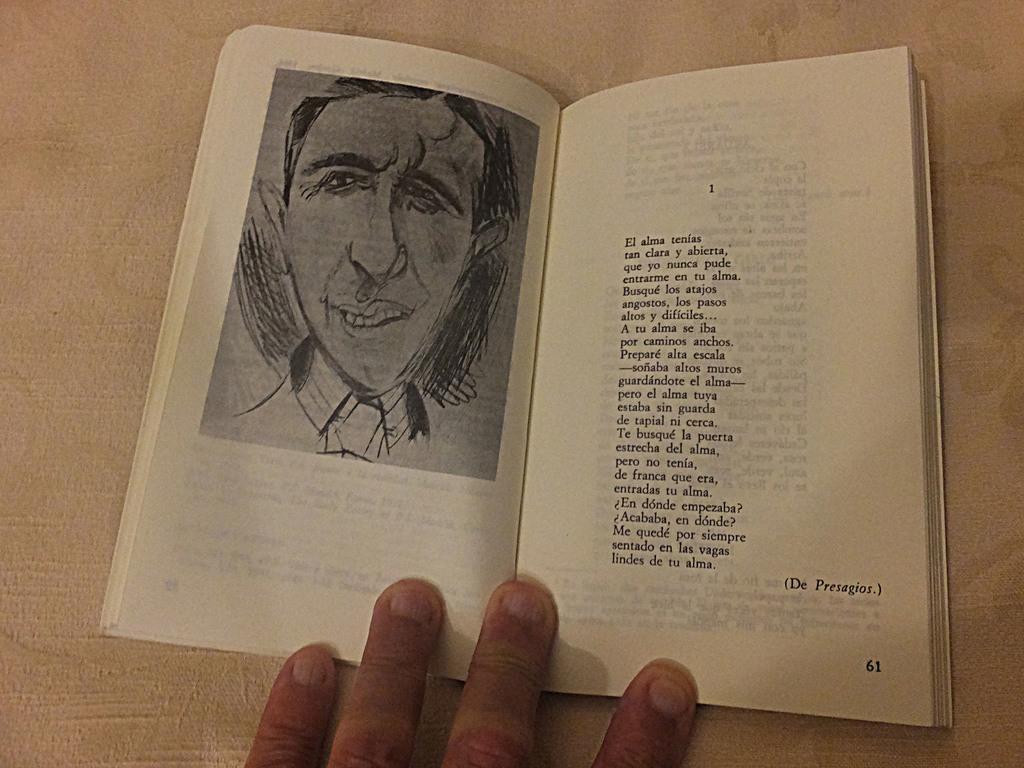How would you summarize this image in a sentence or two? There is a book in the center of the image, there is text and an image on it and a hand at the bottom side. 